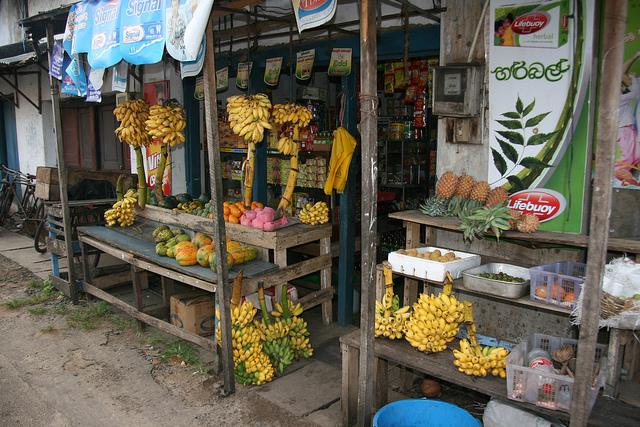What is the brand Lifebuoy selling?

Choices:
A) clothing
B) shampoo
C) soap
D) backpacks soap 